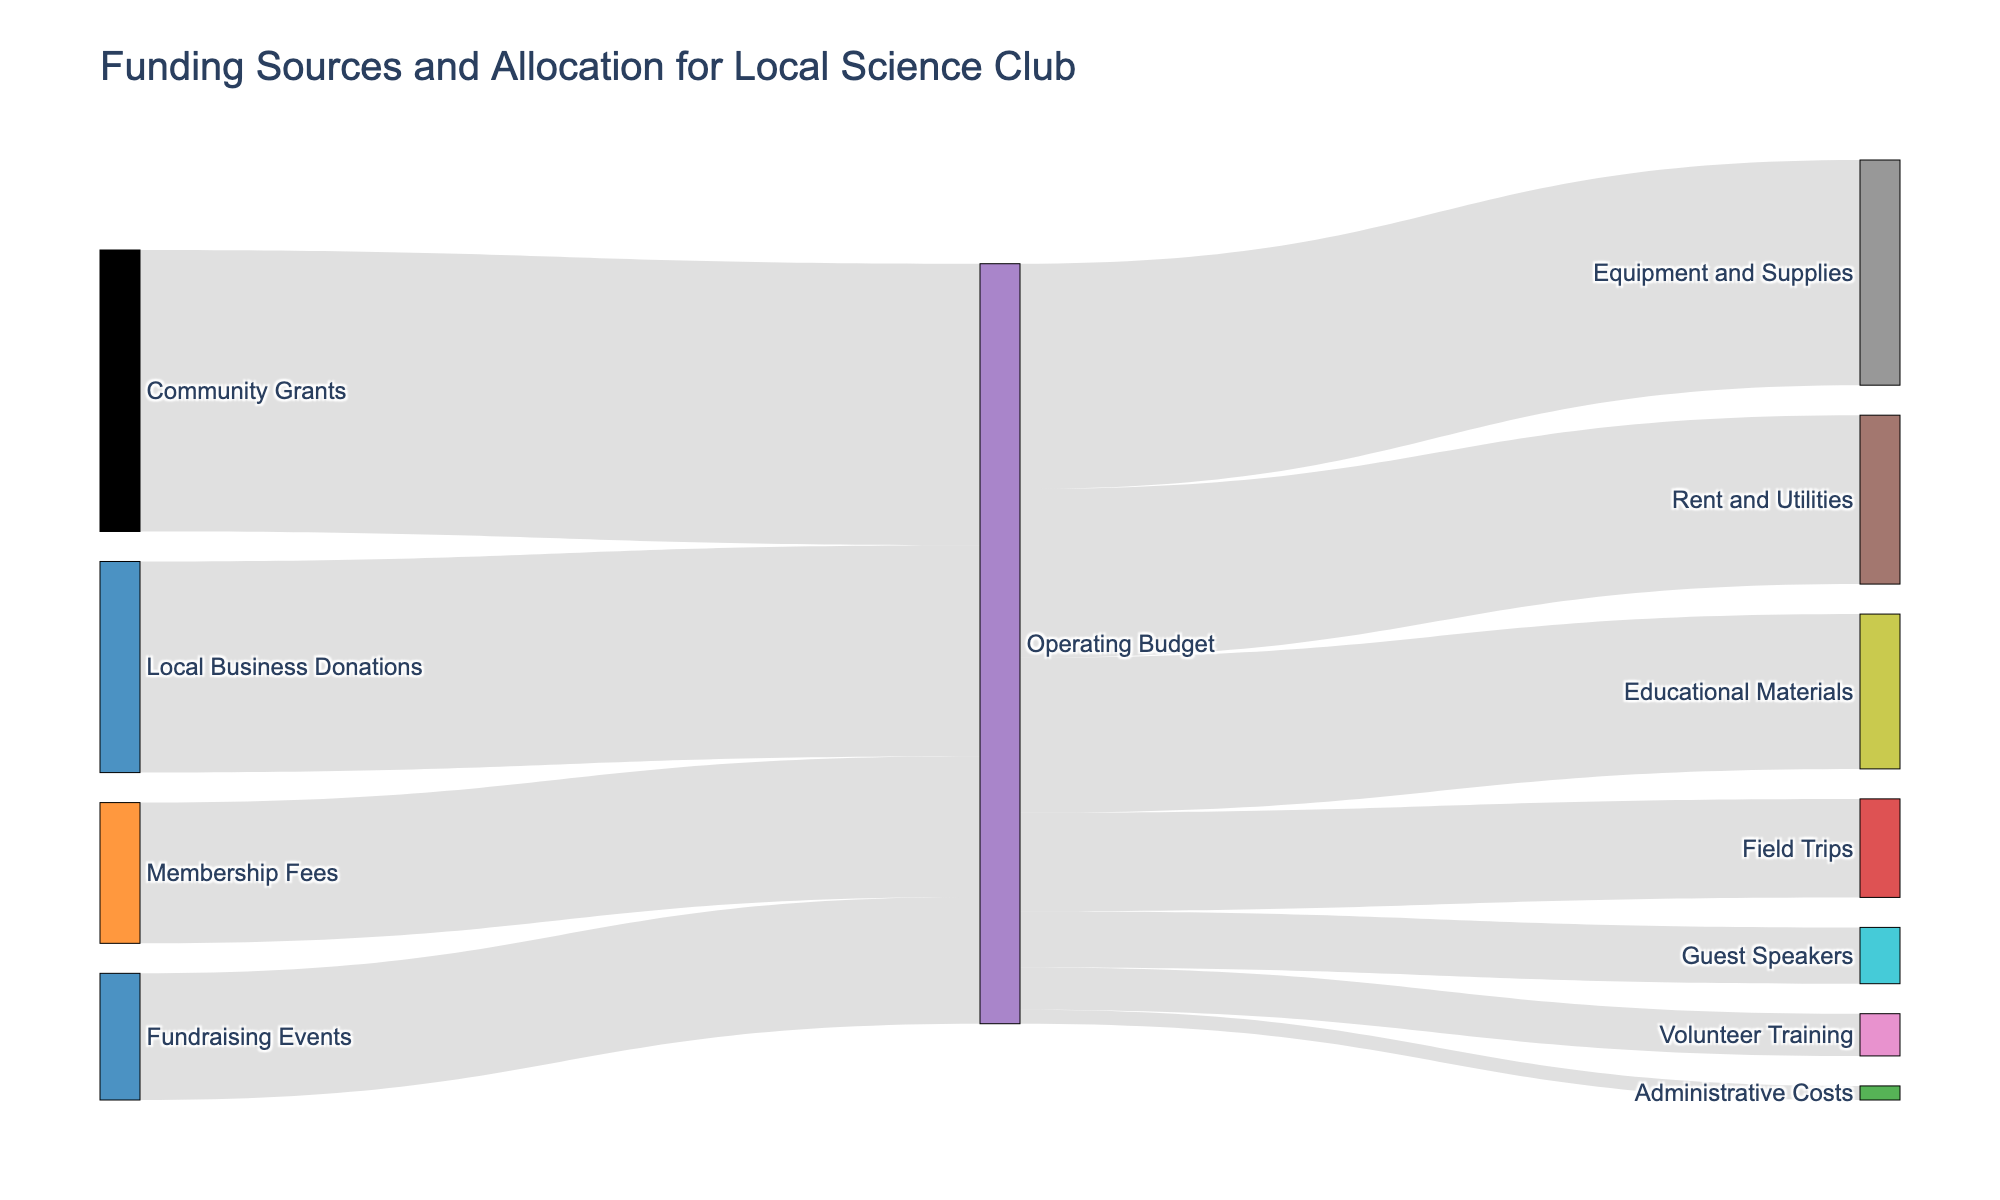What are the main sources of funding for the science club? There are four sources listed on the left side of the Sankey diagram: Membership Fees, Local Business Donations, Community Grants, and Fundraising Events.
Answer: Membership Fees, Local Business Donations, Community Grants, Fundraising Events How much funding is provided by Community Grants? The flow from Community Grants to the Operating Budget shows a value of 10,000.
Answer: 10,000 What is the largest single expenditure category in the Operating Budget? The flows from the Operating Budget to each expenditure category show that Equipment and Supplies has the largest value at 8,000.
Answer: Equipment and Supplies How much total funding is allocated to Educational Materials and Field Trips combined? Add the values for Educational Materials (5,500) and Field Trips (3,500) for a total of 9,000.
Answer: 9,000 Which funding source contributes the least amount to the Operating Budget? The flows from the funding sources to the Operating Budget show that Fundraising Events contribute the least with a value of 4,500.
Answer: Fundraising Events How much money is allocated to Rent and Utilities, and how does this compare to Administrative Costs? Rent and Utilities is allocated 6,000 and Administrative Costs are allocated 500. Rent and Utilities receives 5,500 more than Administrative Costs.
Answer: Rent and Utilities receives 5,500 more than Administrative Costs What percentage of the total generated funds is allocated to Guest Speakers? The total funds (5,000 + 7,500 + 10,000 + 4,500 = 27,000) and the amount allocated to Guest Speakers (2,000). The percentage is (2,000 / 27,000) * 100 ≈ 7.4%.
Answer: 7.4% Compare the sum of the contributions from Membership Fees and Local Business Donations to the sum of Community Grants and Fundraising Events. Which is higher? Sum of Membership Fees and Local Business Donations is (5,000 + 7,500 = 12,500) and sum of Community Grants and Fundraising Events is (10,000 + 4,500 = 14,500). Community Grants and Fundraising Events is higher.
Answer: Community Grants and Fundraising Events is higher How many categories receive allocations from the Operating Budget? The number of unique categories connected to the Operating Budget via flows is seven: Rent and Utilities, Equipment and Supplies, Educational Materials, Field Trips, Guest Speakers, Volunteer Training, and Administrative Costs.
Answer: Seven What percentage of the Operating Budget is allocated to Equipment and Supplies? The total Operating Budget is 27,000, and 8,000 is allocated to Equipment and Supplies. The percentage is (8,000 / 27,000) * 100 ≈ 29.6%.
Answer: 29.6% 